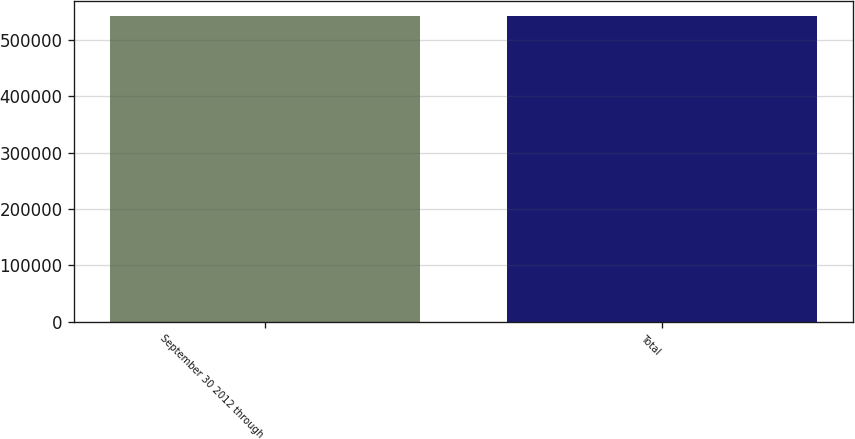Convert chart to OTSL. <chart><loc_0><loc_0><loc_500><loc_500><bar_chart><fcel>September 30 2012 through<fcel>Total<nl><fcel>542251<fcel>542251<nl></chart> 